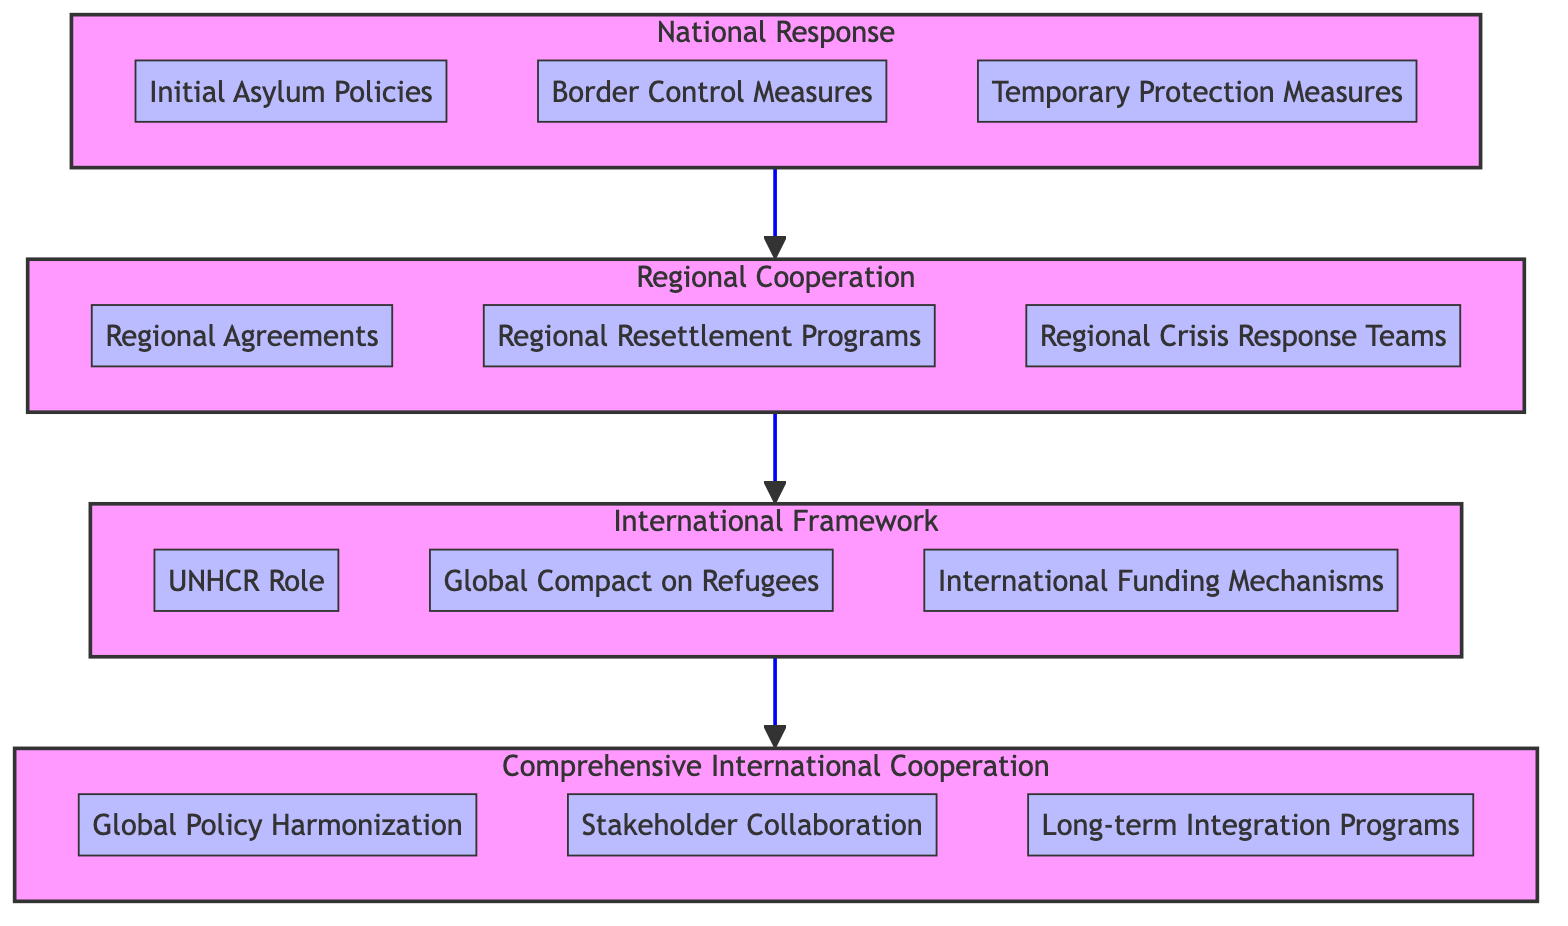What level is the "Global Compact on Refugees" found in? "Global Compact on Refugees" is located in the International Framework level, which is detailed in the diagram with its components aligned under each respective level.
Answer: International Framework How many components are listed under "Regional Cooperation"? The Regional Cooperation level contains three specific components: Regional Agreements, Regional Resettlement Programs, and Regional Crisis Response Teams, making a total of three listed components.
Answer: 3 Which component in the "Comprehensive International Cooperation" level focuses on long-term solutions? The component that centers around long-term solutions in the Comprehensive International Cooperation level is "Long-term Integration Programs," which is specifically aimed at developing sustainable solutions for refugee integration.
Answer: Long-term Integration Programs What is the immediate level above "National Response"? Following the flow of the diagram, the level that comes directly above "National Response" is "Regional Cooperation," which shows the next stage in the progression of refugee protection policies.
Answer: Regional Cooperation What role does "UNHCR" play in the "International Framework"? In the International Framework, "UNHCR Role" refers to the function that the United Nations High Commissioner for Refugees has in coordinating international efforts and providing guidelines, making it fundamental to the framework.
Answer: UNHCR Role Which component is shared between "Regional Cooperation" and "International Framework"? The component that facilitates the transition from "Regional Cooperation" to the "International Framework" is "Regional Resettlement Programs," as it highlights the efforts made at both regional and international levels to address refugee needs.
Answer: Regional Resettlement Programs What is the purpose of "Stakeholder Collaboration"? The purpose of "Stakeholder Collaboration" within the Comprehensive International Cooperation level emphasizes the combined efforts by governments, NGOs, and international organizations aimed at protecting and empowering refugees.
Answer: Stakeholder Collaboration How does the flow of the diagram demonstrate the transition from national to international levels? The diagram outlines a clear upward flow from the National Response level to the Comprehensive International Cooperation level, indicating the progression and increasing complexity of refugee protection policies as they evolve from national policies to cooperative international efforts.
Answer: Comprehensive International Cooperation 